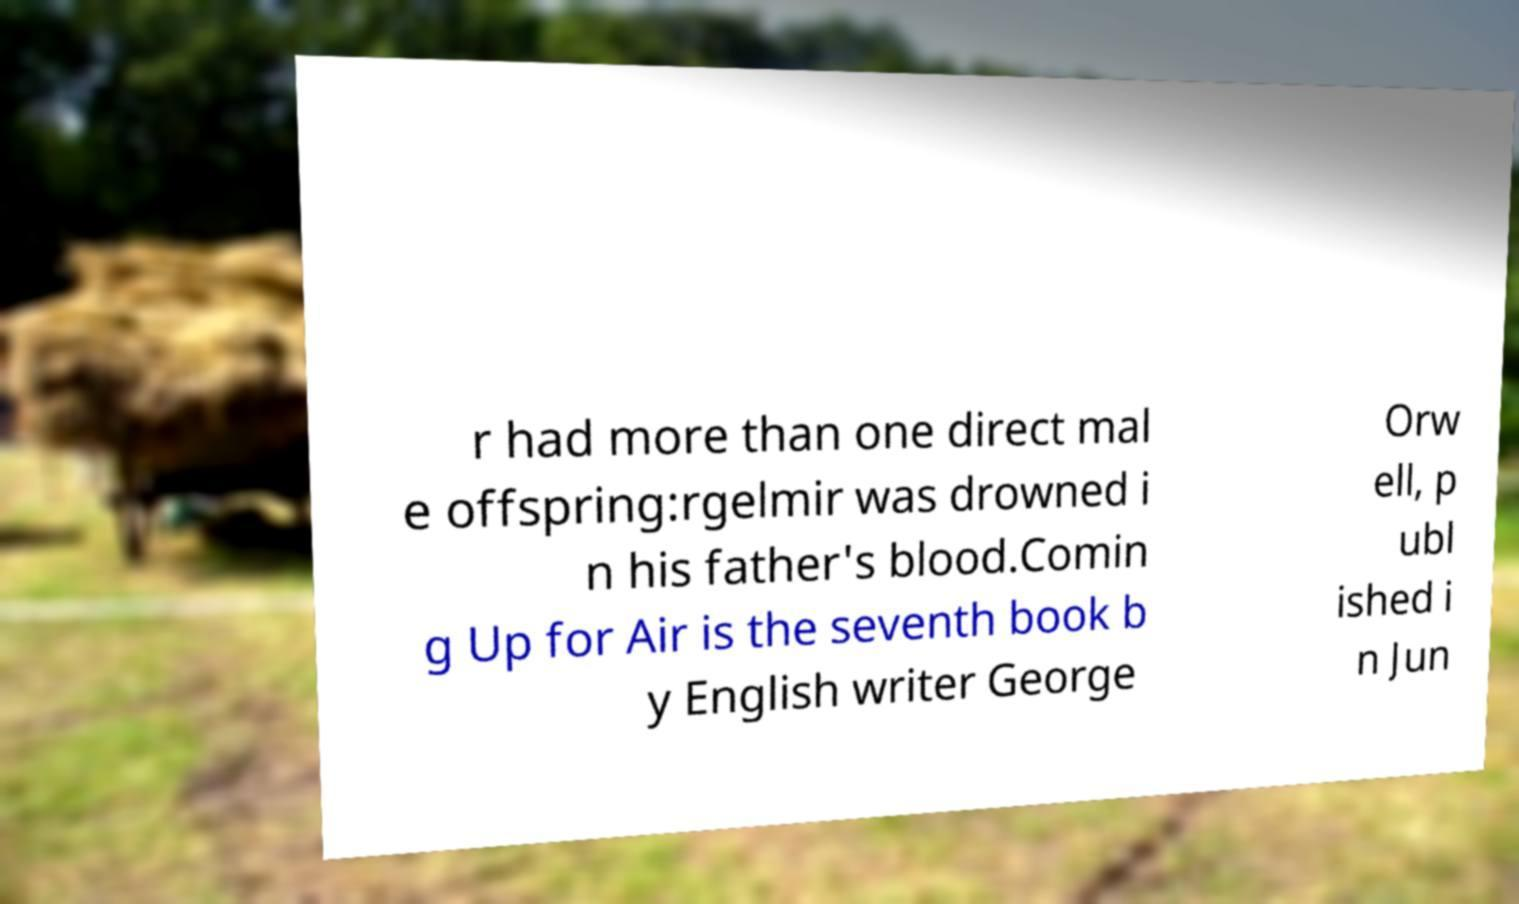Can you read and provide the text displayed in the image?This photo seems to have some interesting text. Can you extract and type it out for me? r had more than one direct mal e offspring:rgelmir was drowned i n his father's blood.Comin g Up for Air is the seventh book b y English writer George Orw ell, p ubl ished i n Jun 